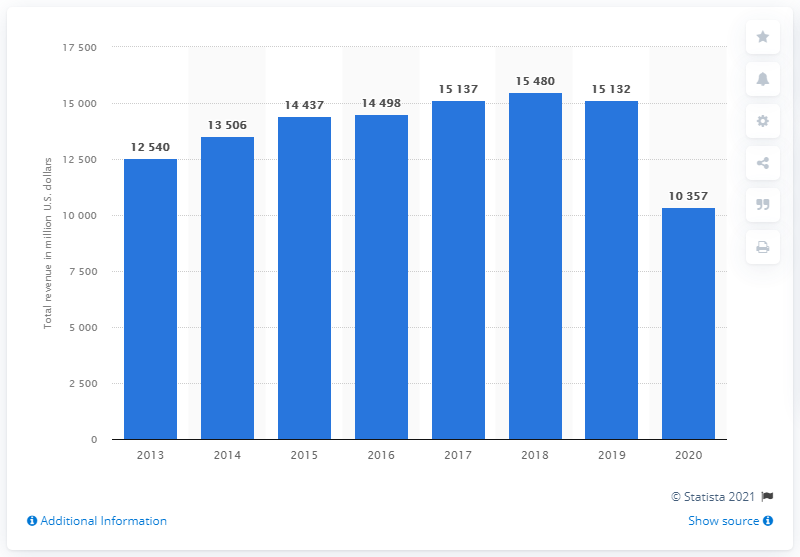Specify some key components in this picture. Nordstrom's global revenue in dollars in 2020 was 10,357. 